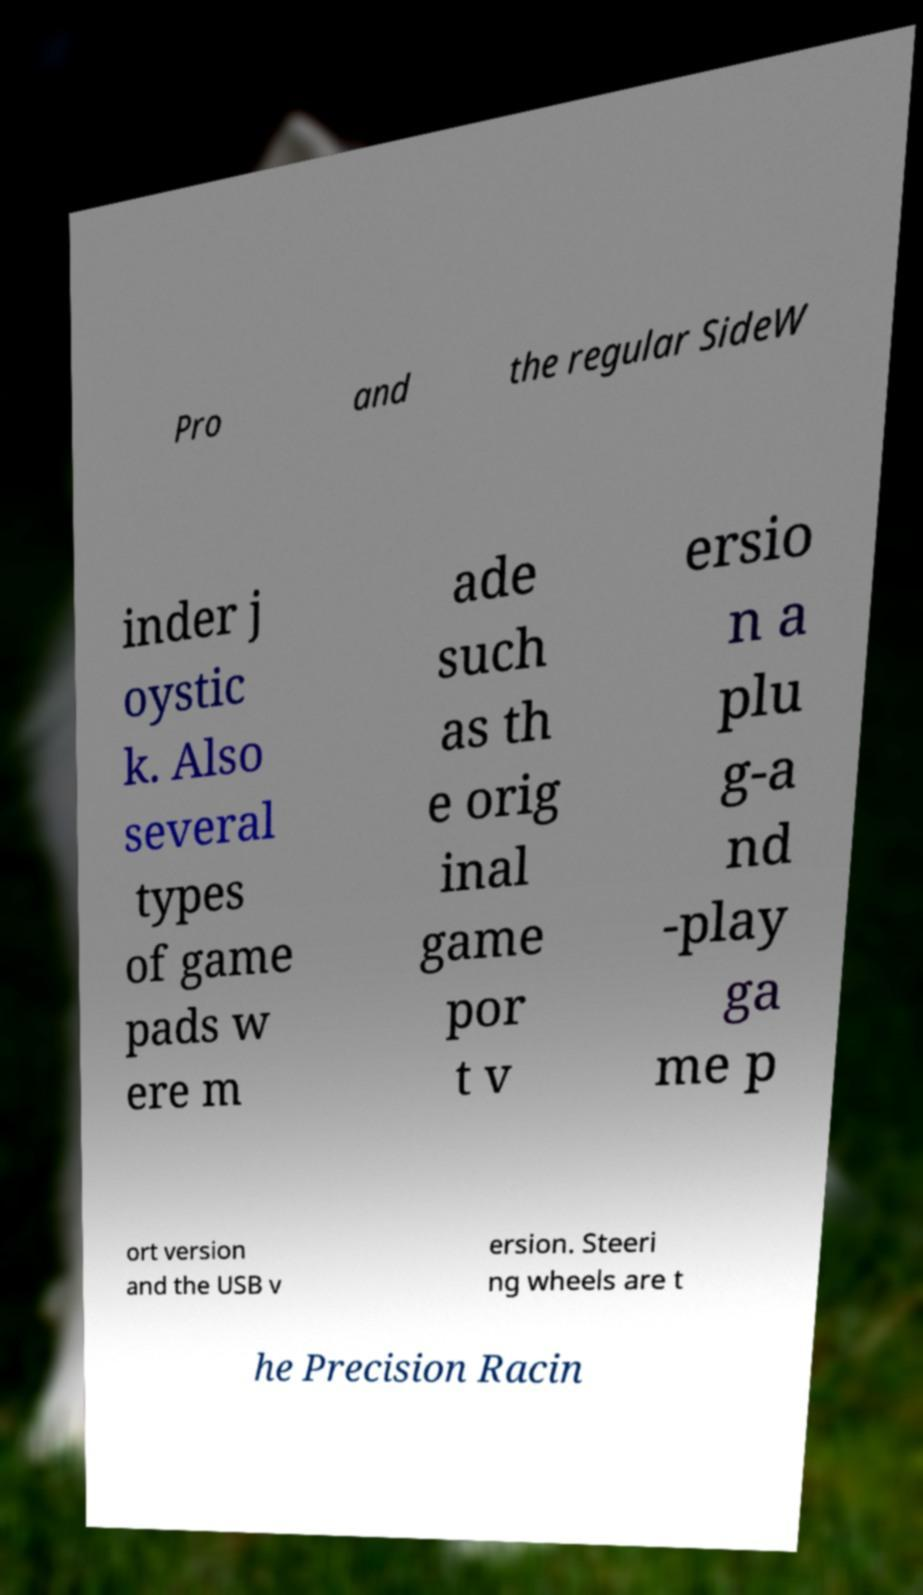Please read and relay the text visible in this image. What does it say? Pro and the regular SideW inder j oystic k. Also several types of game pads w ere m ade such as th e orig inal game por t v ersio n a plu g-a nd -play ga me p ort version and the USB v ersion. Steeri ng wheels are t he Precision Racin 